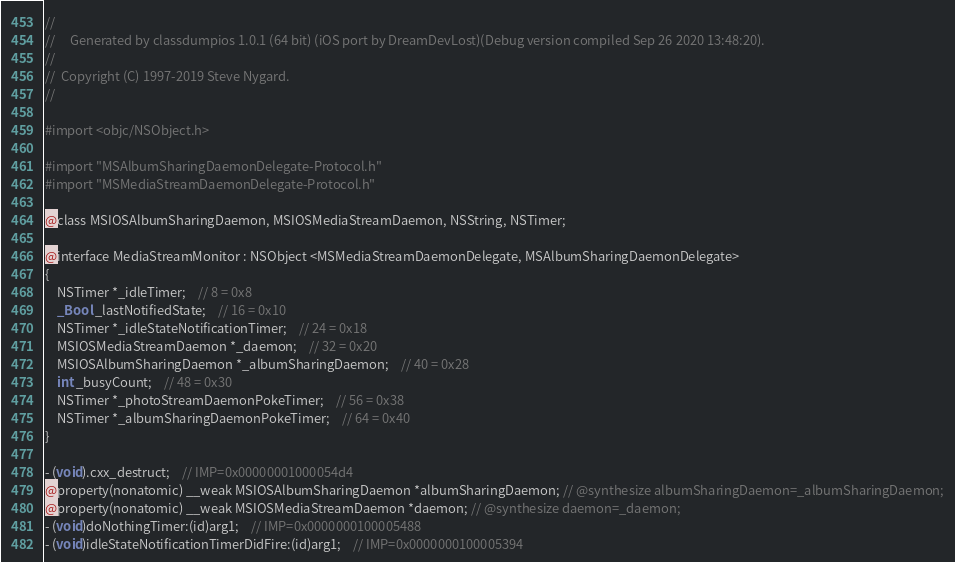<code> <loc_0><loc_0><loc_500><loc_500><_C_>//
//     Generated by classdumpios 1.0.1 (64 bit) (iOS port by DreamDevLost)(Debug version compiled Sep 26 2020 13:48:20).
//
//  Copyright (C) 1997-2019 Steve Nygard.
//

#import <objc/NSObject.h>

#import "MSAlbumSharingDaemonDelegate-Protocol.h"
#import "MSMediaStreamDaemonDelegate-Protocol.h"

@class MSIOSAlbumSharingDaemon, MSIOSMediaStreamDaemon, NSString, NSTimer;

@interface MediaStreamMonitor : NSObject <MSMediaStreamDaemonDelegate, MSAlbumSharingDaemonDelegate>
{
    NSTimer *_idleTimer;	// 8 = 0x8
    _Bool _lastNotifiedState;	// 16 = 0x10
    NSTimer *_idleStateNotificationTimer;	// 24 = 0x18
    MSIOSMediaStreamDaemon *_daemon;	// 32 = 0x20
    MSIOSAlbumSharingDaemon *_albumSharingDaemon;	// 40 = 0x28
    int _busyCount;	// 48 = 0x30
    NSTimer *_photoStreamDaemonPokeTimer;	// 56 = 0x38
    NSTimer *_albumSharingDaemonPokeTimer;	// 64 = 0x40
}

- (void).cxx_destruct;	// IMP=0x00000001000054d4
@property(nonatomic) __weak MSIOSAlbumSharingDaemon *albumSharingDaemon; // @synthesize albumSharingDaemon=_albumSharingDaemon;
@property(nonatomic) __weak MSIOSMediaStreamDaemon *daemon; // @synthesize daemon=_daemon;
- (void)doNothingTimer:(id)arg1;	// IMP=0x0000000100005488
- (void)idleStateNotificationTimerDidFire:(id)arg1;	// IMP=0x0000000100005394</code> 